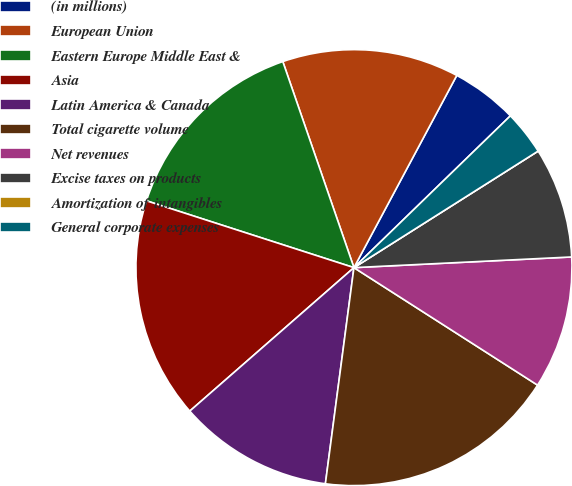Convert chart. <chart><loc_0><loc_0><loc_500><loc_500><pie_chart><fcel>(in millions)<fcel>European Union<fcel>Eastern Europe Middle East &<fcel>Asia<fcel>Latin America & Canada<fcel>Total cigarette volume<fcel>Net revenues<fcel>Excise taxes on products<fcel>Amortization of intangibles<fcel>General corporate expenses<nl><fcel>4.92%<fcel>13.11%<fcel>14.75%<fcel>16.39%<fcel>11.48%<fcel>18.03%<fcel>9.84%<fcel>8.2%<fcel>0.0%<fcel>3.28%<nl></chart> 